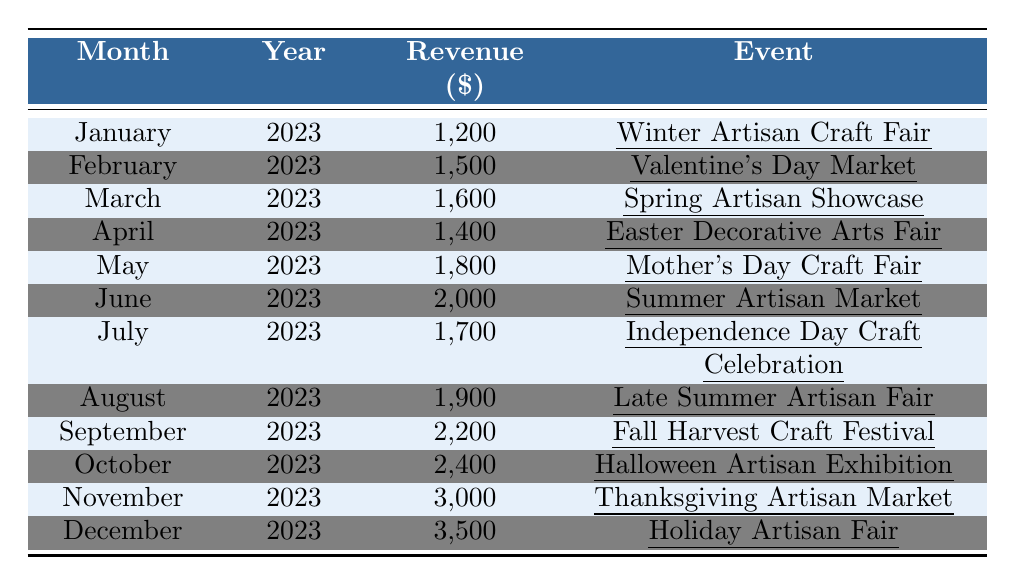What was the revenue for June 2023? The table lists the revenue for June 2023 as $2,000 associated with the "Summer Artisan Market" event.
Answer: $2,000 Which month had the highest revenue in 2023? The highest revenue is recorded in December 2023, amounting to $3,500 during the "Holiday Artisan Fair."
Answer: December What is the total revenue generated from the craft fairs in 2023? Summing all monthly revenues: $1,200 + $1,500 + $1,600 + $1,400 + $1,800 + $2,000 + $1,700 + $1,900 + $2,200 + $2,400 + $3,000 + $3,500 = $23,300.
Answer: $23,300 How much more revenue was generated in November compared to January? The revenue for November is $3,000, and for January, it is $1,200. The difference is $3,000 - $1,200 = $1,800.
Answer: $1,800 Did the revenue increase every month from January to December? Comparing each month's revenue, there are fluctuations; the revenue does not increase every month (it decreased from March to April and from July to August).
Answer: No What is the average revenue per month for the second half of the year (July to December)? The total revenue for these months is $1,700 + $1,900 + $2,200 + $2,400 + $3,000 + $3,500 = $14,700. There are 6 months, so the average revenue is $14,700 / 6 = $2,450.
Answer: $2,450 Which event in September generated the most revenue up to that month? The revenue for September, which is $2,200 from the "Fall Harvest Craft Festival," is compared to previous months. It turns out to be the highest when compared with all prior months.
Answer: Yes What was the change in revenue from the "Easter Decorative Arts Fair" in April to the "Mother's Day Craft Fair" in May? April's revenue was $1,400 and May's was $1,800. The change is $1,800 - $1,400 = $400 increase.
Answer: $400 increase Which event was associated with the lowest revenue for February? February's event was the "Valentine's Day Market," and the revenue was $1,500, which is lower than the revenues of subsequent months up to that point.
Answer: Valentine's Day Market, $1,500 What was the total revenue for the first quarter (January to March)? Summing the revenues of January ($1,200), February ($1,500), and March ($1,600): $1,200 + $1,500 + $1,600 = $4,300.
Answer: $4,300 How much revenue did the craft fairs generate in the summer months (June to August)? The revenue for summer months is June ($2,000), July ($1,700), and August ($1,900); so total revenue = $2,000 + $1,700 + $1,900 = $5,600.
Answer: $5,600 